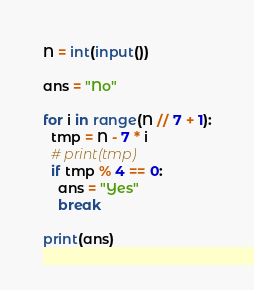<code> <loc_0><loc_0><loc_500><loc_500><_Python_>N = int(input())

ans = "No"

for i in range(N // 7 + 1):
  tmp = N - 7 * i
  # print(tmp)
  if tmp % 4 == 0:
    ans = "Yes"
    break
    
print(ans)</code> 